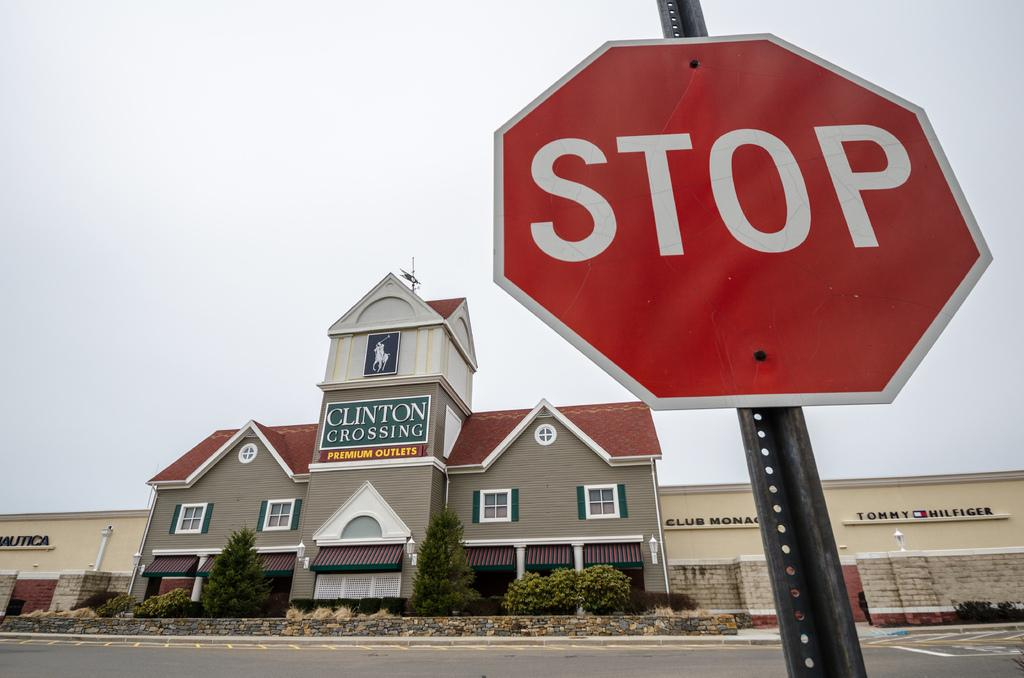<image>
Share a concise interpretation of the image provided. Clinton Crossing has a stop sign in front of it. 